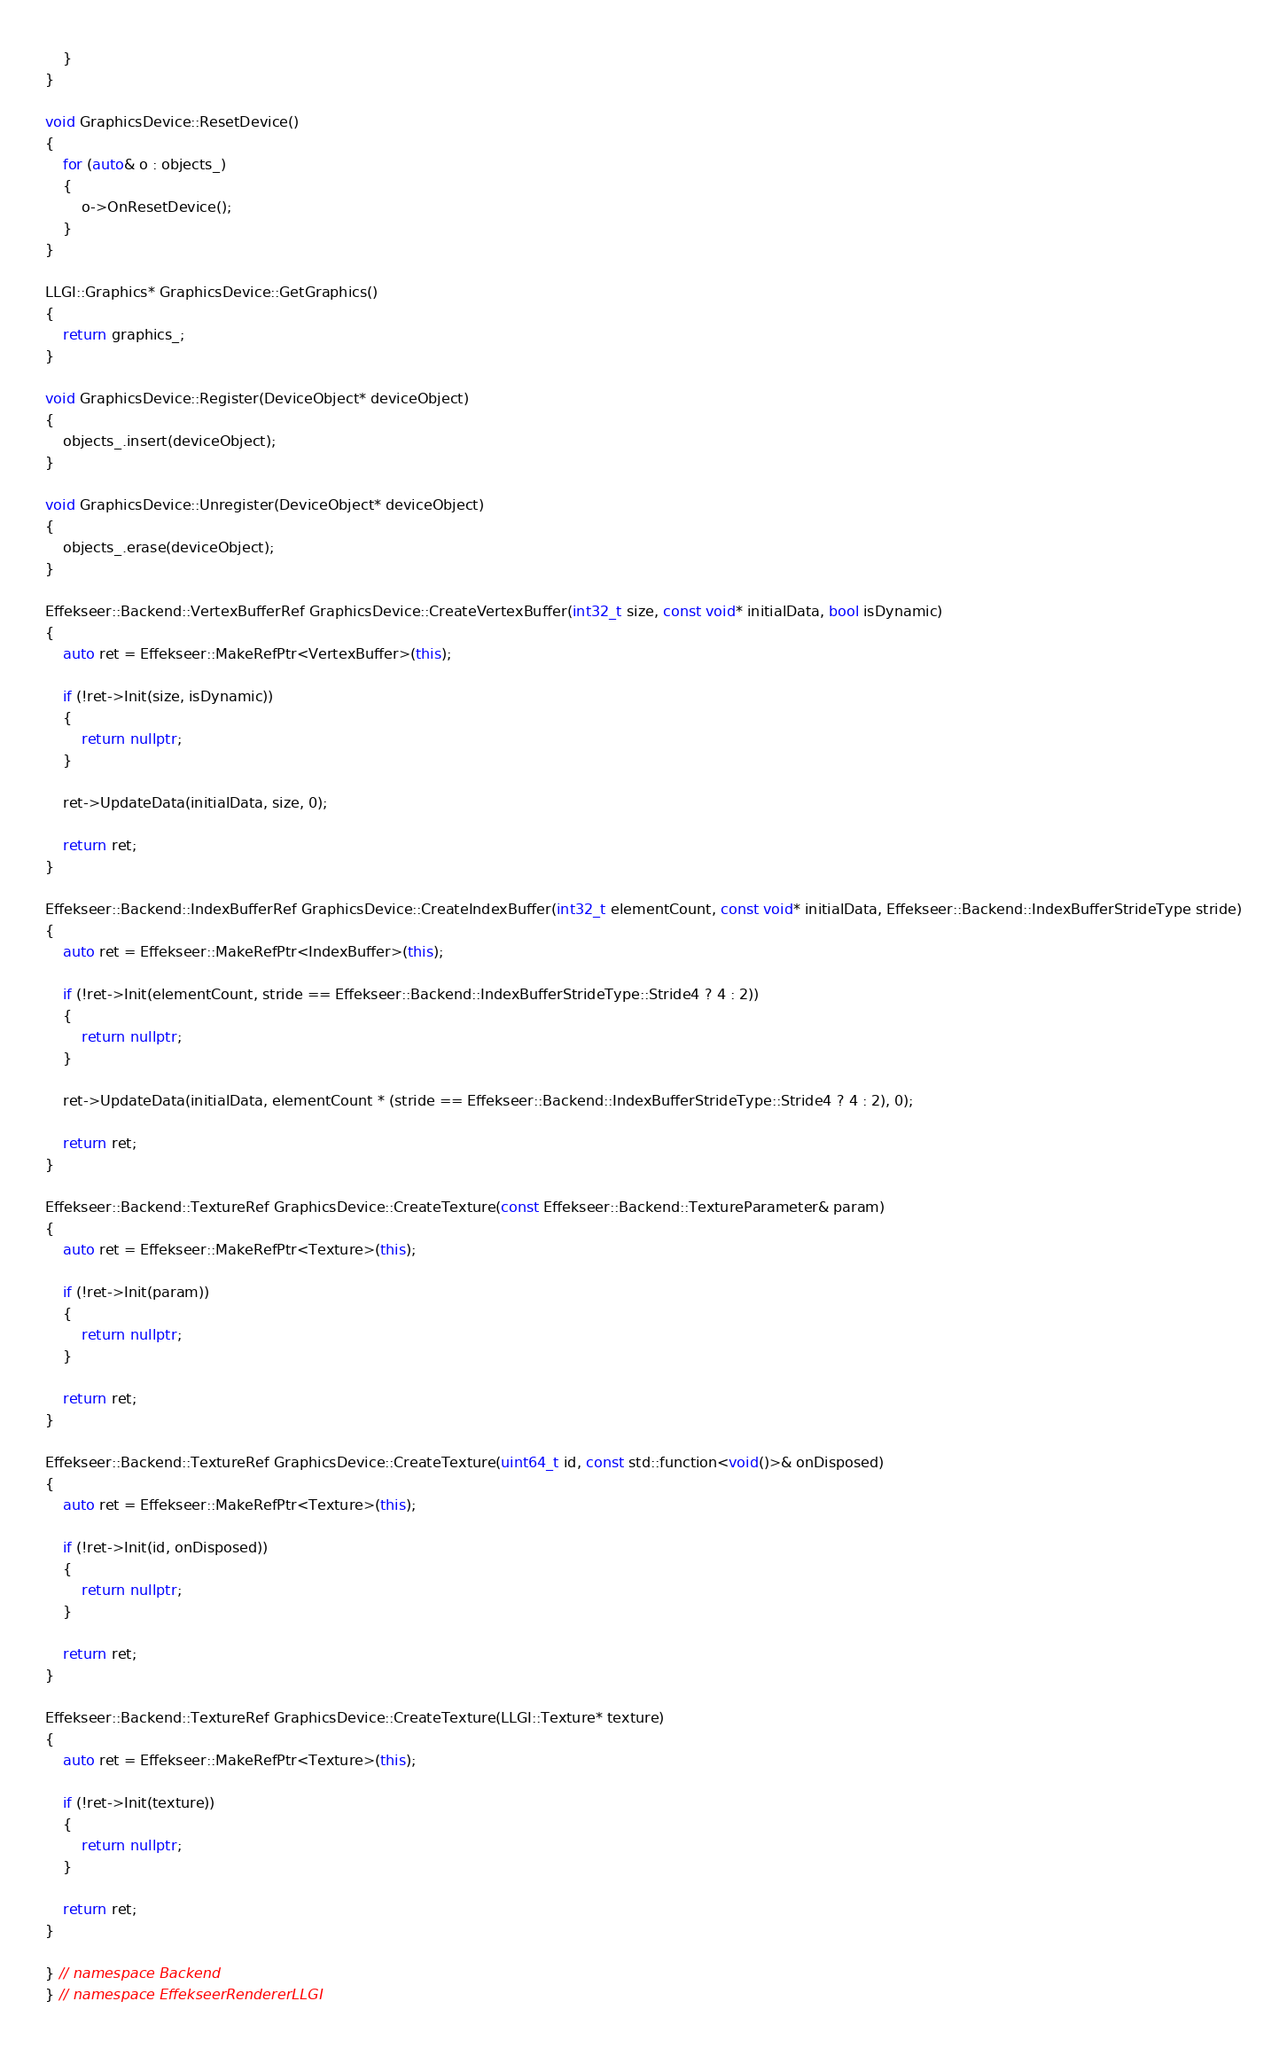<code> <loc_0><loc_0><loc_500><loc_500><_C++_>	}
}

void GraphicsDevice::ResetDevice()
{
	for (auto& o : objects_)
	{
		o->OnResetDevice();
	}
}

LLGI::Graphics* GraphicsDevice::GetGraphics()
{
	return graphics_;
}

void GraphicsDevice::Register(DeviceObject* deviceObject)
{
	objects_.insert(deviceObject);
}

void GraphicsDevice::Unregister(DeviceObject* deviceObject)
{
	objects_.erase(deviceObject);
}

Effekseer::Backend::VertexBufferRef GraphicsDevice::CreateVertexBuffer(int32_t size, const void* initialData, bool isDynamic)
{
	auto ret = Effekseer::MakeRefPtr<VertexBuffer>(this);

	if (!ret->Init(size, isDynamic))
	{
		return nullptr;
	}

	ret->UpdateData(initialData, size, 0);

	return ret;
}

Effekseer::Backend::IndexBufferRef GraphicsDevice::CreateIndexBuffer(int32_t elementCount, const void* initialData, Effekseer::Backend::IndexBufferStrideType stride)
{
	auto ret = Effekseer::MakeRefPtr<IndexBuffer>(this);

	if (!ret->Init(elementCount, stride == Effekseer::Backend::IndexBufferStrideType::Stride4 ? 4 : 2))
	{
		return nullptr;
	}

	ret->UpdateData(initialData, elementCount * (stride == Effekseer::Backend::IndexBufferStrideType::Stride4 ? 4 : 2), 0);

	return ret;
}

Effekseer::Backend::TextureRef GraphicsDevice::CreateTexture(const Effekseer::Backend::TextureParameter& param)
{
	auto ret = Effekseer::MakeRefPtr<Texture>(this);

	if (!ret->Init(param))
	{
		return nullptr;
	}

	return ret;
}

Effekseer::Backend::TextureRef GraphicsDevice::CreateTexture(uint64_t id, const std::function<void()>& onDisposed)
{
	auto ret = Effekseer::MakeRefPtr<Texture>(this);

	if (!ret->Init(id, onDisposed))
	{
		return nullptr;
	}

	return ret;
}

Effekseer::Backend::TextureRef GraphicsDevice::CreateTexture(LLGI::Texture* texture)
{
	auto ret = Effekseer::MakeRefPtr<Texture>(this);

	if (!ret->Init(texture))
	{
		return nullptr;
	}

	return ret;
}

} // namespace Backend
} // namespace EffekseerRendererLLGI</code> 